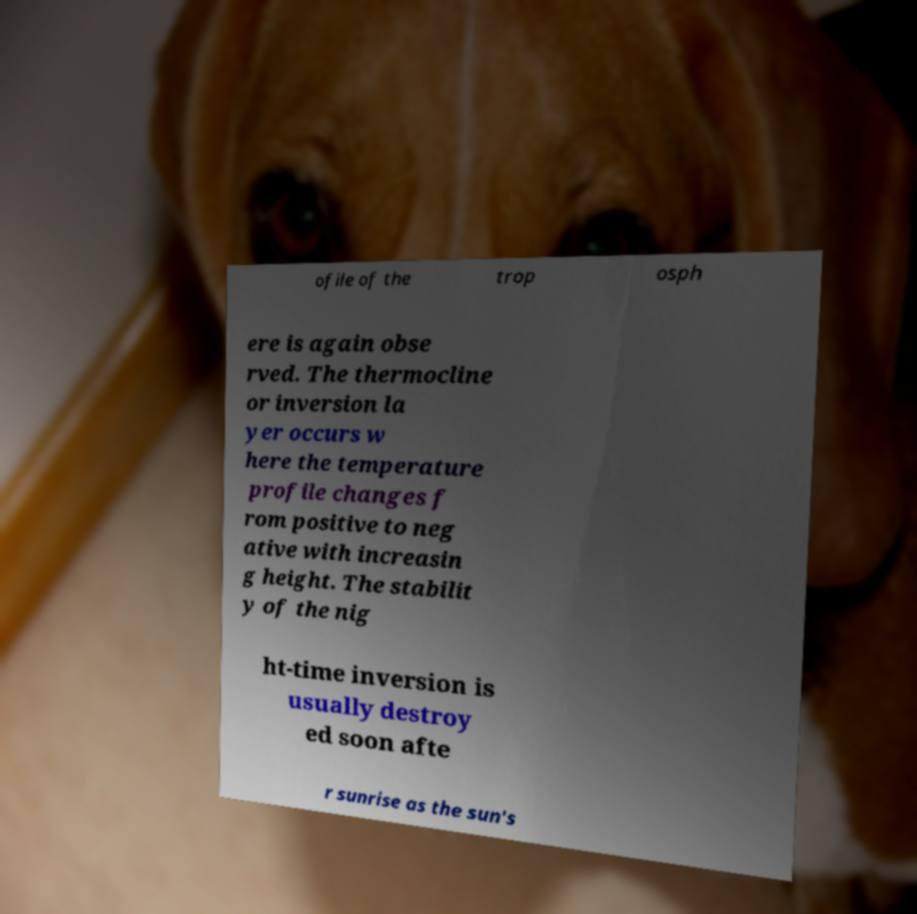Please read and relay the text visible in this image. What does it say? ofile of the trop osph ere is again obse rved. The thermocline or inversion la yer occurs w here the temperature profile changes f rom positive to neg ative with increasin g height. The stabilit y of the nig ht-time inversion is usually destroy ed soon afte r sunrise as the sun's 